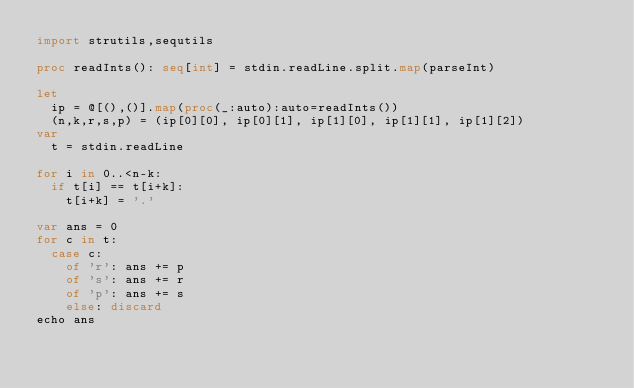Convert code to text. <code><loc_0><loc_0><loc_500><loc_500><_Nim_>import strutils,sequtils

proc readInts(): seq[int] = stdin.readLine.split.map(parseInt)

let
  ip = @[(),()].map(proc(_:auto):auto=readInts())
  (n,k,r,s,p) = (ip[0][0], ip[0][1], ip[1][0], ip[1][1], ip[1][2])
var
  t = stdin.readLine

for i in 0..<n-k:
  if t[i] == t[i+k]:
    t[i+k] = '.'

var ans = 0
for c in t:
  case c:
    of 'r': ans += p
    of 's': ans += r
    of 'p': ans += s
    else: discard
echo ans</code> 